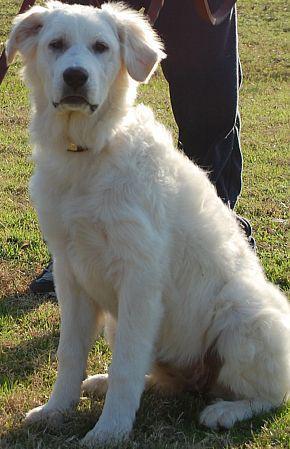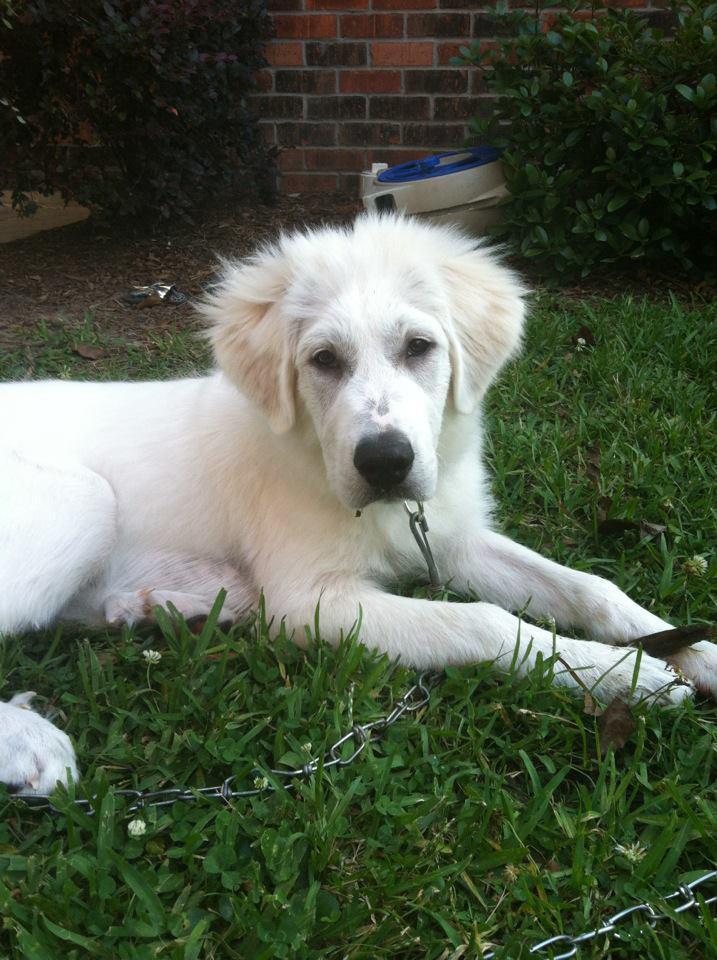The first image is the image on the left, the second image is the image on the right. For the images displayed, is the sentence "One of the images features a single dog laying on grass." factually correct? Answer yes or no. Yes. 